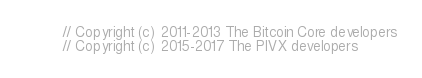Convert code to text. <code><loc_0><loc_0><loc_500><loc_500><_ObjectiveC_>// Copyright (c) 2011-2013 The Bitcoin Core developers
// Copyright (c) 2015-2017 The PIVX developers</code> 